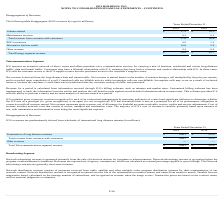According to Hc2 Holdings's financial document, How is the net revenue derived? derived from the long-distance data and transit traffic.. The document states: "Net revenue is derived from the long-distance data and transit traffic. Net revenue is earned based on the number of minutes during a call multiplied ..." Also, How is the revenue for a period calculated? from information received through ICS’s billing software, such as minutes and market rates.. The document states: "Revenue for a period is calculated from information received through ICS’s billing software, such as minutes and market rates. Customized billing soft..." Also, What was the termination of long distance minutes in 2019? According to the financial document, $696.1 (in millions). The relevant text states: "Termination of long distance minutes $ 696.1 $ 793.6..." Also, can you calculate: What is the change in the Termination of long distance minutes from 2018 to 2019? Based on the calculation: 696.1 - 793.6, the result is -97.5 (in millions). This is based on the information: "Termination of long distance minutes $ 696.1 $ 793.6 Termination of long distance minutes $ 696.1 $ 793.6..." The key data points involved are: 696.1, 793.6. Also, can you calculate: What is the average Total revenue from contracts with customers for 2018 and 2019? To answer this question, I need to perform calculations using the financial data. The calculation is: (696.1 + 793.6) / 2, which equals 744.85 (in millions). This is based on the information: "Termination of long distance minutes $ 696.1 $ 793.6 Termination of long distance minutes $ 696.1 $ 793.6..." The key data points involved are: 696.1, 793.6. Also, can you calculate: What is the percentage change in the Total Telecommunications segment revenue from 2018 to 2019? To answer this question, I need to perform calculations using the financial data. The calculation is: 696.1 / 793.6 - 1, which equals -12.29 (percentage). This is based on the information: "Termination of long distance minutes $ 696.1 $ 793.6 Termination of long distance minutes $ 696.1 $ 793.6..." The key data points involved are: 696.1, 793.6. 